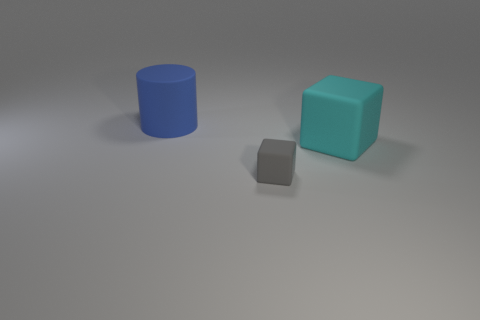Add 1 big blue metallic balls. How many objects exist? 4 Subtract all cubes. How many objects are left? 1 Subtract all gray blocks. Subtract all small gray blocks. How many objects are left? 1 Add 2 cyan blocks. How many cyan blocks are left? 3 Add 3 tiny rubber blocks. How many tiny rubber blocks exist? 4 Subtract 0 cyan cylinders. How many objects are left? 3 